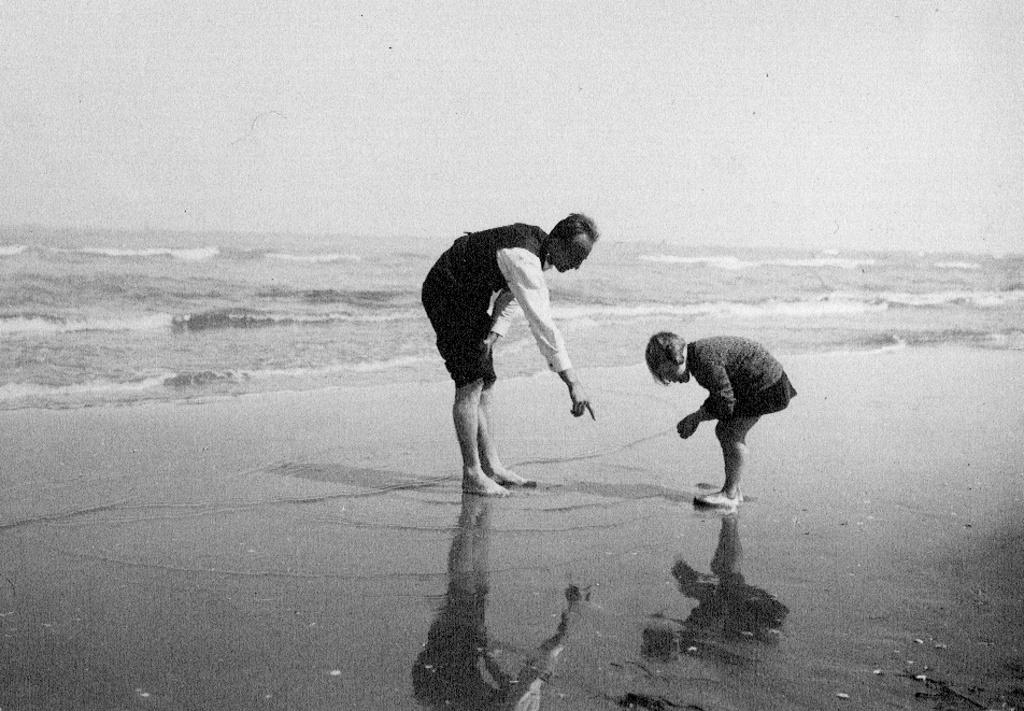What is the primary element in the image? There is water in the image. Can you describe the people in the image? There are two people standing in the image. What can be seen in the background of the image? The sky is visible in the image. What type of celery can be seen growing in the water in the image? There is no celery present in the image; it only features water and two people standing. Can you hear the people talking in the image? The image is a visual representation, so we cannot hear the people talking. 